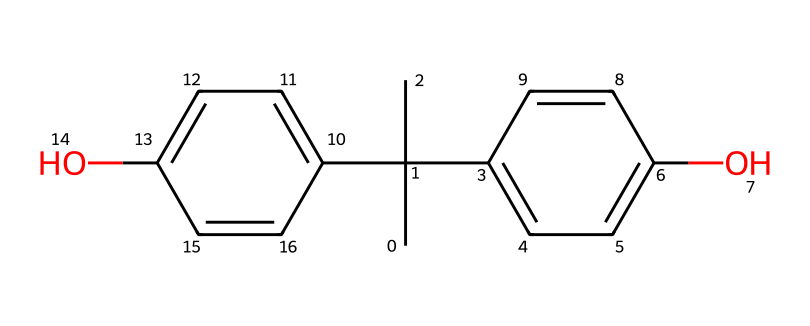What is the molecular formula of BPA? By analyzing the SMILES representation, we identify the number of carbon (C), hydrogen (H), and oxygen (O) atoms present. There are 15 carbon atoms, 16 hydrogen atoms, and 2 oxygen atoms in the structure. Therefore, the molecular formula is derived from the counts of these atoms.
Answer: C15H16O2 How many rings are present in the BPA structure? The structure contains two distinct aromatic rings, evident from the connected cyclic arrangements in the SMILES. Each ring consists of alternating double bonds and single bonds, commonly found in benzene derivatives, confirming the presence of two rings.
Answer: two What type of chemical bonding is dominant in BPA? The chemical structure shows a combination of single and double bonds between the atoms, typical of organic compounds, with double bonds being more prominent in the aromatic rings. This indicates that covalent bonding is the dominant type within the chemical structure.
Answer: covalent What functional groups are present in BPA? The chemical structure contains hydroxyl (-OH) groups indicated by the presence of oxygen atoms directly bonded to carbon. These groups are responsible for BPA's classification as a phenolic compound, which is characterized by aromatic rings bonded to hydroxyl groups.
Answer: hydroxyl groups Is BPA considered a toxic chemical? BPA has been extensively studied and is associated with various health concerns, including endocrine disruption and reproductive toxicity. Regulatory agencies have classified it as a toxic substance, particularly regarding its use in consumer products such as plastic water bottles.
Answer: yes Does BPA exhibit any special properties due to its structure? The presence of hydroxyl functional groups in BPA contributes to its ability to interact with biological systems, affecting hormonal activity. The structural features also enhance its solubility in certain environments, which leads to its widespread environmental presence and biological impact.
Answer: yes 